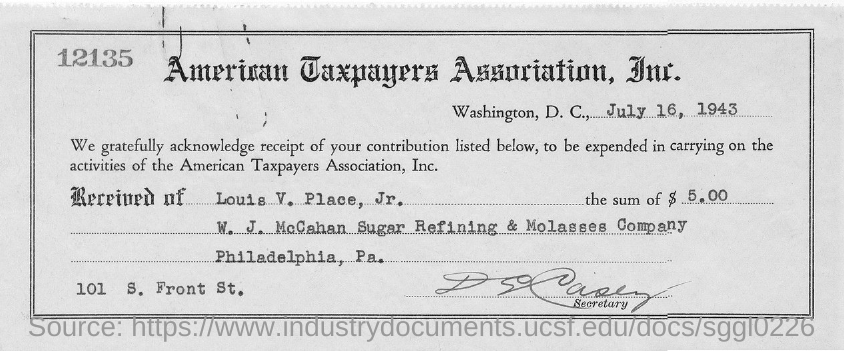Provide the receipt number printed at the left top corner of the receipt?
Give a very brief answer. 12135. Which "Association" has given the receipt?
Your answer should be compact. American Taxpayers Association, Inc. Who has given $ 5.00?
Offer a very short reply. LOUIS V. PLACE, JR. Mention the amount given by "Louis V . Place, Jr."?
Offer a terse response. $ 5.00. Who has signed the receipt?
Provide a short and direct response. SECRETARY. Which date is receipt  given?
Ensure brevity in your answer.  July 16,  1943. Where is "American Taxpayers Association, Inc." located?
Your answer should be compact. Washington,  D.C. 